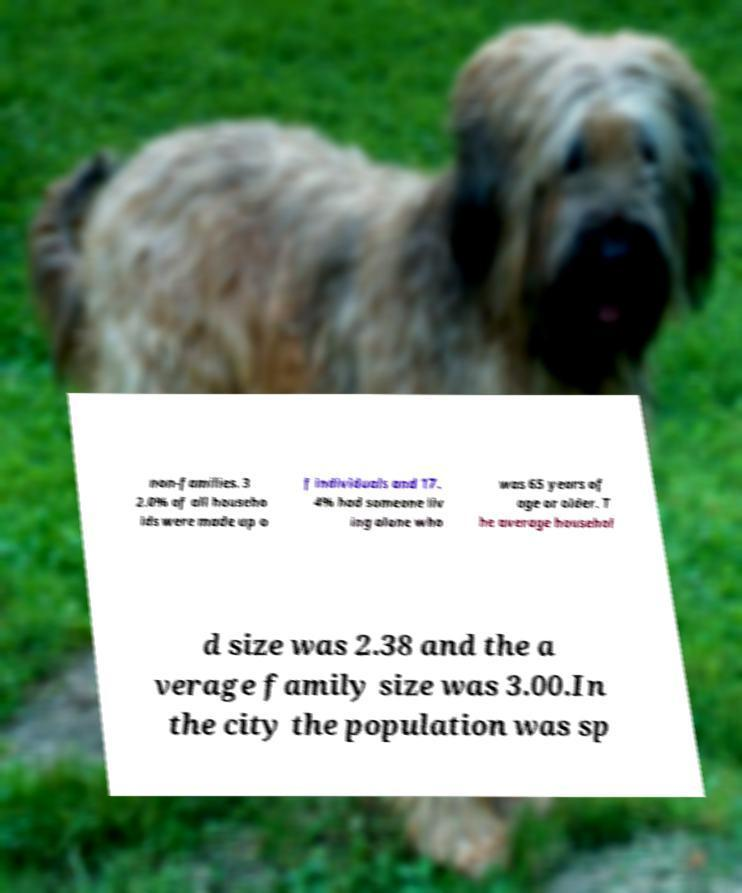Can you accurately transcribe the text from the provided image for me? non-families. 3 2.0% of all househo lds were made up o f individuals and 17. 4% had someone liv ing alone who was 65 years of age or older. T he average househol d size was 2.38 and the a verage family size was 3.00.In the city the population was sp 